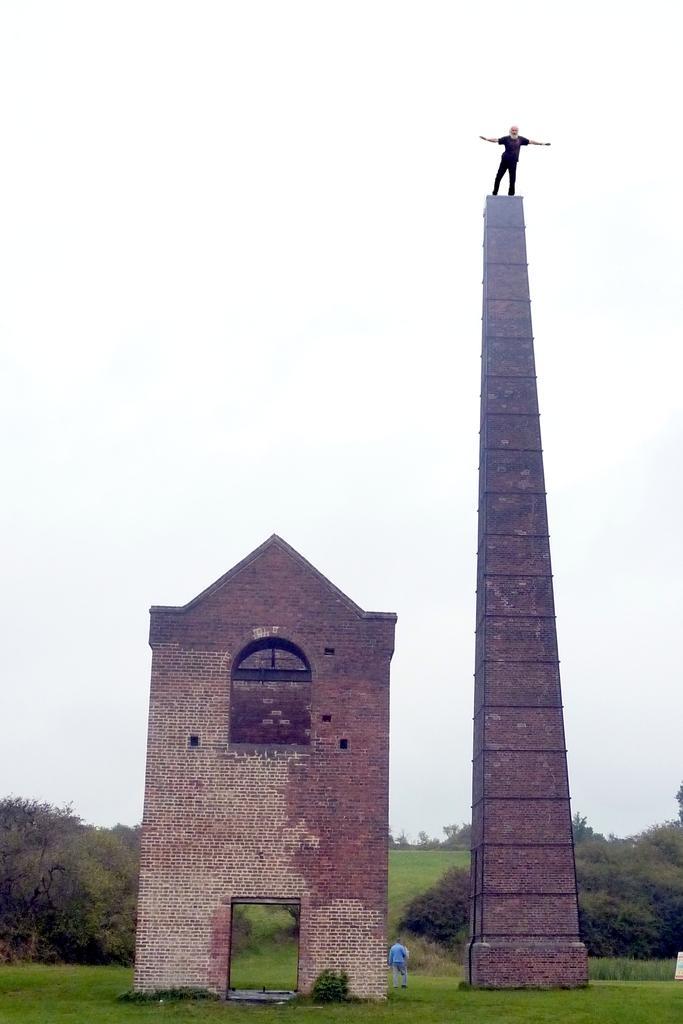Describe this image in one or two sentences. In this image we can see a person on the tower. And we can see a wall with the arch. And we can see the grass and trees. And we can see the sky. 